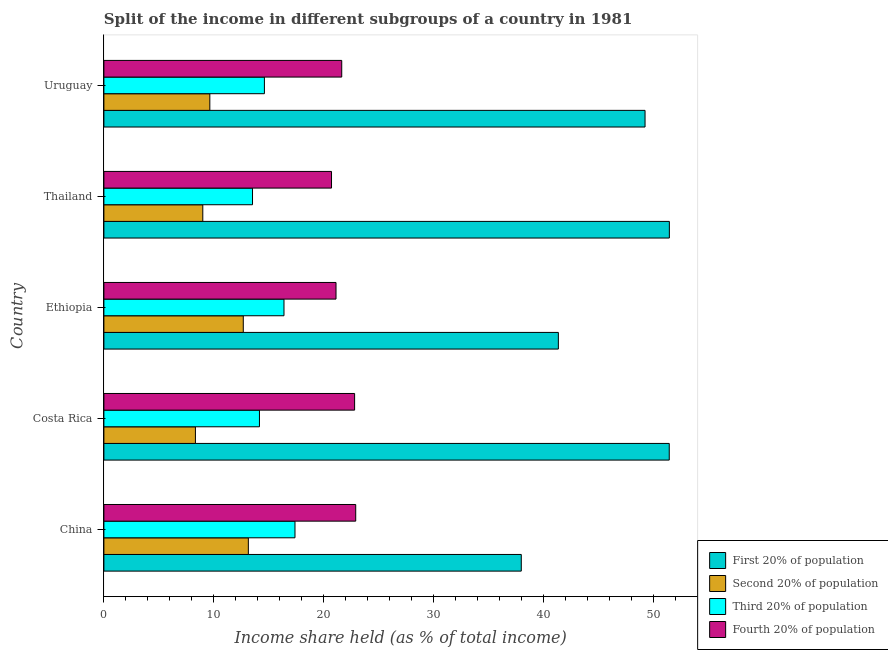How many groups of bars are there?
Offer a very short reply. 5. Are the number of bars per tick equal to the number of legend labels?
Your answer should be very brief. Yes. Are the number of bars on each tick of the Y-axis equal?
Your answer should be compact. Yes. How many bars are there on the 3rd tick from the top?
Provide a succinct answer. 4. How many bars are there on the 1st tick from the bottom?
Ensure brevity in your answer.  4. What is the label of the 1st group of bars from the top?
Keep it short and to the point. Uruguay. What is the share of the income held by second 20% of the population in Uruguay?
Offer a very short reply. 9.63. Across all countries, what is the maximum share of the income held by first 20% of the population?
Your response must be concise. 51.4. Across all countries, what is the minimum share of the income held by third 20% of the population?
Offer a very short reply. 13.51. In which country was the share of the income held by third 20% of the population maximum?
Ensure brevity in your answer.  China. In which country was the share of the income held by third 20% of the population minimum?
Give a very brief answer. Thailand. What is the total share of the income held by first 20% of the population in the graph?
Ensure brevity in your answer.  231.23. What is the difference between the share of the income held by second 20% of the population in China and that in Uruguay?
Ensure brevity in your answer.  3.5. What is the difference between the share of the income held by first 20% of the population in Costa Rica and the share of the income held by third 20% of the population in Uruguay?
Make the answer very short. 36.8. What is the average share of the income held by first 20% of the population per country?
Make the answer very short. 46.25. What is the difference between the share of the income held by fourth 20% of the population and share of the income held by first 20% of the population in Ethiopia?
Your answer should be very brief. -20.21. In how many countries, is the share of the income held by third 20% of the population greater than 8 %?
Provide a succinct answer. 5. What is the ratio of the share of the income held by third 20% of the population in Costa Rica to that in Ethiopia?
Provide a short and direct response. 0.86. Is the share of the income held by first 20% of the population in Thailand less than that in Uruguay?
Provide a short and direct response. No. What is the difference between the highest and the second highest share of the income held by second 20% of the population?
Give a very brief answer. 0.46. What is the difference between the highest and the lowest share of the income held by fourth 20% of the population?
Make the answer very short. 2.2. In how many countries, is the share of the income held by fourth 20% of the population greater than the average share of the income held by fourth 20% of the population taken over all countries?
Your answer should be very brief. 2. Is it the case that in every country, the sum of the share of the income held by second 20% of the population and share of the income held by first 20% of the population is greater than the sum of share of the income held by third 20% of the population and share of the income held by fourth 20% of the population?
Make the answer very short. Yes. What does the 3rd bar from the top in Costa Rica represents?
Offer a very short reply. Second 20% of population. What does the 1st bar from the bottom in Thailand represents?
Make the answer very short. First 20% of population. How many bars are there?
Ensure brevity in your answer.  20. What is the difference between two consecutive major ticks on the X-axis?
Your answer should be very brief. 10. Does the graph contain any zero values?
Your answer should be compact. No. Does the graph contain grids?
Offer a very short reply. No. Where does the legend appear in the graph?
Your answer should be compact. Bottom right. How many legend labels are there?
Your response must be concise. 4. What is the title of the graph?
Ensure brevity in your answer.  Split of the income in different subgroups of a country in 1981. What is the label or title of the X-axis?
Provide a short and direct response. Income share held (as % of total income). What is the Income share held (as % of total income) of First 20% of population in China?
Provide a short and direct response. 37.94. What is the Income share held (as % of total income) in Second 20% of population in China?
Offer a terse response. 13.13. What is the Income share held (as % of total income) in Third 20% of population in China?
Keep it short and to the point. 17.37. What is the Income share held (as % of total income) of Fourth 20% of population in China?
Offer a very short reply. 22.89. What is the Income share held (as % of total income) in First 20% of population in Costa Rica?
Offer a very short reply. 51.39. What is the Income share held (as % of total income) in Second 20% of population in Costa Rica?
Your answer should be compact. 8.32. What is the Income share held (as % of total income) of Third 20% of population in Costa Rica?
Keep it short and to the point. 14.14. What is the Income share held (as % of total income) in Fourth 20% of population in Costa Rica?
Your answer should be very brief. 22.79. What is the Income share held (as % of total income) of First 20% of population in Ethiopia?
Give a very brief answer. 41.31. What is the Income share held (as % of total income) in Second 20% of population in Ethiopia?
Offer a terse response. 12.67. What is the Income share held (as % of total income) in Third 20% of population in Ethiopia?
Provide a succinct answer. 16.37. What is the Income share held (as % of total income) of Fourth 20% of population in Ethiopia?
Provide a succinct answer. 21.1. What is the Income share held (as % of total income) of First 20% of population in Thailand?
Provide a short and direct response. 51.4. What is the Income share held (as % of total income) in Second 20% of population in Thailand?
Give a very brief answer. 8.99. What is the Income share held (as % of total income) of Third 20% of population in Thailand?
Make the answer very short. 13.51. What is the Income share held (as % of total income) in Fourth 20% of population in Thailand?
Offer a terse response. 20.69. What is the Income share held (as % of total income) in First 20% of population in Uruguay?
Provide a succinct answer. 49.19. What is the Income share held (as % of total income) of Second 20% of population in Uruguay?
Keep it short and to the point. 9.63. What is the Income share held (as % of total income) of Third 20% of population in Uruguay?
Provide a succinct answer. 14.59. What is the Income share held (as % of total income) in Fourth 20% of population in Uruguay?
Your answer should be very brief. 21.62. Across all countries, what is the maximum Income share held (as % of total income) in First 20% of population?
Keep it short and to the point. 51.4. Across all countries, what is the maximum Income share held (as % of total income) in Second 20% of population?
Keep it short and to the point. 13.13. Across all countries, what is the maximum Income share held (as % of total income) of Third 20% of population?
Offer a terse response. 17.37. Across all countries, what is the maximum Income share held (as % of total income) in Fourth 20% of population?
Make the answer very short. 22.89. Across all countries, what is the minimum Income share held (as % of total income) in First 20% of population?
Keep it short and to the point. 37.94. Across all countries, what is the minimum Income share held (as % of total income) in Second 20% of population?
Ensure brevity in your answer.  8.32. Across all countries, what is the minimum Income share held (as % of total income) of Third 20% of population?
Offer a terse response. 13.51. Across all countries, what is the minimum Income share held (as % of total income) of Fourth 20% of population?
Your response must be concise. 20.69. What is the total Income share held (as % of total income) in First 20% of population in the graph?
Keep it short and to the point. 231.23. What is the total Income share held (as % of total income) of Second 20% of population in the graph?
Keep it short and to the point. 52.74. What is the total Income share held (as % of total income) of Third 20% of population in the graph?
Keep it short and to the point. 75.98. What is the total Income share held (as % of total income) in Fourth 20% of population in the graph?
Offer a terse response. 109.09. What is the difference between the Income share held (as % of total income) in First 20% of population in China and that in Costa Rica?
Your response must be concise. -13.45. What is the difference between the Income share held (as % of total income) of Second 20% of population in China and that in Costa Rica?
Offer a terse response. 4.81. What is the difference between the Income share held (as % of total income) in Third 20% of population in China and that in Costa Rica?
Provide a succinct answer. 3.23. What is the difference between the Income share held (as % of total income) in First 20% of population in China and that in Ethiopia?
Your answer should be compact. -3.37. What is the difference between the Income share held (as % of total income) of Second 20% of population in China and that in Ethiopia?
Your answer should be very brief. 0.46. What is the difference between the Income share held (as % of total income) of Fourth 20% of population in China and that in Ethiopia?
Offer a very short reply. 1.79. What is the difference between the Income share held (as % of total income) in First 20% of population in China and that in Thailand?
Offer a very short reply. -13.46. What is the difference between the Income share held (as % of total income) of Second 20% of population in China and that in Thailand?
Provide a succinct answer. 4.14. What is the difference between the Income share held (as % of total income) of Third 20% of population in China and that in Thailand?
Make the answer very short. 3.86. What is the difference between the Income share held (as % of total income) of First 20% of population in China and that in Uruguay?
Give a very brief answer. -11.25. What is the difference between the Income share held (as % of total income) of Third 20% of population in China and that in Uruguay?
Give a very brief answer. 2.78. What is the difference between the Income share held (as % of total income) of Fourth 20% of population in China and that in Uruguay?
Provide a short and direct response. 1.27. What is the difference between the Income share held (as % of total income) of First 20% of population in Costa Rica and that in Ethiopia?
Give a very brief answer. 10.08. What is the difference between the Income share held (as % of total income) of Second 20% of population in Costa Rica and that in Ethiopia?
Make the answer very short. -4.35. What is the difference between the Income share held (as % of total income) in Third 20% of population in Costa Rica and that in Ethiopia?
Offer a very short reply. -2.23. What is the difference between the Income share held (as % of total income) in Fourth 20% of population in Costa Rica and that in Ethiopia?
Provide a succinct answer. 1.69. What is the difference between the Income share held (as % of total income) of First 20% of population in Costa Rica and that in Thailand?
Provide a succinct answer. -0.01. What is the difference between the Income share held (as % of total income) of Second 20% of population in Costa Rica and that in Thailand?
Your answer should be very brief. -0.67. What is the difference between the Income share held (as % of total income) of Third 20% of population in Costa Rica and that in Thailand?
Offer a very short reply. 0.63. What is the difference between the Income share held (as % of total income) in Fourth 20% of population in Costa Rica and that in Thailand?
Your response must be concise. 2.1. What is the difference between the Income share held (as % of total income) in First 20% of population in Costa Rica and that in Uruguay?
Give a very brief answer. 2.2. What is the difference between the Income share held (as % of total income) in Second 20% of population in Costa Rica and that in Uruguay?
Your answer should be very brief. -1.31. What is the difference between the Income share held (as % of total income) in Third 20% of population in Costa Rica and that in Uruguay?
Provide a succinct answer. -0.45. What is the difference between the Income share held (as % of total income) in Fourth 20% of population in Costa Rica and that in Uruguay?
Provide a short and direct response. 1.17. What is the difference between the Income share held (as % of total income) of First 20% of population in Ethiopia and that in Thailand?
Your answer should be very brief. -10.09. What is the difference between the Income share held (as % of total income) of Second 20% of population in Ethiopia and that in Thailand?
Offer a terse response. 3.68. What is the difference between the Income share held (as % of total income) of Third 20% of population in Ethiopia and that in Thailand?
Keep it short and to the point. 2.86. What is the difference between the Income share held (as % of total income) of Fourth 20% of population in Ethiopia and that in Thailand?
Make the answer very short. 0.41. What is the difference between the Income share held (as % of total income) in First 20% of population in Ethiopia and that in Uruguay?
Your response must be concise. -7.88. What is the difference between the Income share held (as % of total income) of Second 20% of population in Ethiopia and that in Uruguay?
Your answer should be very brief. 3.04. What is the difference between the Income share held (as % of total income) of Third 20% of population in Ethiopia and that in Uruguay?
Make the answer very short. 1.78. What is the difference between the Income share held (as % of total income) in Fourth 20% of population in Ethiopia and that in Uruguay?
Keep it short and to the point. -0.52. What is the difference between the Income share held (as % of total income) in First 20% of population in Thailand and that in Uruguay?
Ensure brevity in your answer.  2.21. What is the difference between the Income share held (as % of total income) of Second 20% of population in Thailand and that in Uruguay?
Your answer should be compact. -0.64. What is the difference between the Income share held (as % of total income) in Third 20% of population in Thailand and that in Uruguay?
Offer a terse response. -1.08. What is the difference between the Income share held (as % of total income) in Fourth 20% of population in Thailand and that in Uruguay?
Your response must be concise. -0.93. What is the difference between the Income share held (as % of total income) of First 20% of population in China and the Income share held (as % of total income) of Second 20% of population in Costa Rica?
Give a very brief answer. 29.62. What is the difference between the Income share held (as % of total income) of First 20% of population in China and the Income share held (as % of total income) of Third 20% of population in Costa Rica?
Ensure brevity in your answer.  23.8. What is the difference between the Income share held (as % of total income) in First 20% of population in China and the Income share held (as % of total income) in Fourth 20% of population in Costa Rica?
Your response must be concise. 15.15. What is the difference between the Income share held (as % of total income) of Second 20% of population in China and the Income share held (as % of total income) of Third 20% of population in Costa Rica?
Your answer should be compact. -1.01. What is the difference between the Income share held (as % of total income) in Second 20% of population in China and the Income share held (as % of total income) in Fourth 20% of population in Costa Rica?
Your answer should be very brief. -9.66. What is the difference between the Income share held (as % of total income) of Third 20% of population in China and the Income share held (as % of total income) of Fourth 20% of population in Costa Rica?
Give a very brief answer. -5.42. What is the difference between the Income share held (as % of total income) of First 20% of population in China and the Income share held (as % of total income) of Second 20% of population in Ethiopia?
Provide a short and direct response. 25.27. What is the difference between the Income share held (as % of total income) in First 20% of population in China and the Income share held (as % of total income) in Third 20% of population in Ethiopia?
Your answer should be compact. 21.57. What is the difference between the Income share held (as % of total income) of First 20% of population in China and the Income share held (as % of total income) of Fourth 20% of population in Ethiopia?
Provide a short and direct response. 16.84. What is the difference between the Income share held (as % of total income) in Second 20% of population in China and the Income share held (as % of total income) in Third 20% of population in Ethiopia?
Your answer should be compact. -3.24. What is the difference between the Income share held (as % of total income) in Second 20% of population in China and the Income share held (as % of total income) in Fourth 20% of population in Ethiopia?
Offer a very short reply. -7.97. What is the difference between the Income share held (as % of total income) of Third 20% of population in China and the Income share held (as % of total income) of Fourth 20% of population in Ethiopia?
Ensure brevity in your answer.  -3.73. What is the difference between the Income share held (as % of total income) of First 20% of population in China and the Income share held (as % of total income) of Second 20% of population in Thailand?
Keep it short and to the point. 28.95. What is the difference between the Income share held (as % of total income) of First 20% of population in China and the Income share held (as % of total income) of Third 20% of population in Thailand?
Your answer should be very brief. 24.43. What is the difference between the Income share held (as % of total income) of First 20% of population in China and the Income share held (as % of total income) of Fourth 20% of population in Thailand?
Make the answer very short. 17.25. What is the difference between the Income share held (as % of total income) in Second 20% of population in China and the Income share held (as % of total income) in Third 20% of population in Thailand?
Your response must be concise. -0.38. What is the difference between the Income share held (as % of total income) of Second 20% of population in China and the Income share held (as % of total income) of Fourth 20% of population in Thailand?
Keep it short and to the point. -7.56. What is the difference between the Income share held (as % of total income) of Third 20% of population in China and the Income share held (as % of total income) of Fourth 20% of population in Thailand?
Provide a succinct answer. -3.32. What is the difference between the Income share held (as % of total income) of First 20% of population in China and the Income share held (as % of total income) of Second 20% of population in Uruguay?
Offer a terse response. 28.31. What is the difference between the Income share held (as % of total income) of First 20% of population in China and the Income share held (as % of total income) of Third 20% of population in Uruguay?
Offer a terse response. 23.35. What is the difference between the Income share held (as % of total income) in First 20% of population in China and the Income share held (as % of total income) in Fourth 20% of population in Uruguay?
Provide a succinct answer. 16.32. What is the difference between the Income share held (as % of total income) of Second 20% of population in China and the Income share held (as % of total income) of Third 20% of population in Uruguay?
Give a very brief answer. -1.46. What is the difference between the Income share held (as % of total income) in Second 20% of population in China and the Income share held (as % of total income) in Fourth 20% of population in Uruguay?
Offer a very short reply. -8.49. What is the difference between the Income share held (as % of total income) in Third 20% of population in China and the Income share held (as % of total income) in Fourth 20% of population in Uruguay?
Provide a succinct answer. -4.25. What is the difference between the Income share held (as % of total income) of First 20% of population in Costa Rica and the Income share held (as % of total income) of Second 20% of population in Ethiopia?
Your answer should be very brief. 38.72. What is the difference between the Income share held (as % of total income) of First 20% of population in Costa Rica and the Income share held (as % of total income) of Third 20% of population in Ethiopia?
Provide a short and direct response. 35.02. What is the difference between the Income share held (as % of total income) of First 20% of population in Costa Rica and the Income share held (as % of total income) of Fourth 20% of population in Ethiopia?
Your answer should be compact. 30.29. What is the difference between the Income share held (as % of total income) of Second 20% of population in Costa Rica and the Income share held (as % of total income) of Third 20% of population in Ethiopia?
Provide a short and direct response. -8.05. What is the difference between the Income share held (as % of total income) of Second 20% of population in Costa Rica and the Income share held (as % of total income) of Fourth 20% of population in Ethiopia?
Provide a short and direct response. -12.78. What is the difference between the Income share held (as % of total income) in Third 20% of population in Costa Rica and the Income share held (as % of total income) in Fourth 20% of population in Ethiopia?
Provide a succinct answer. -6.96. What is the difference between the Income share held (as % of total income) in First 20% of population in Costa Rica and the Income share held (as % of total income) in Second 20% of population in Thailand?
Provide a succinct answer. 42.4. What is the difference between the Income share held (as % of total income) of First 20% of population in Costa Rica and the Income share held (as % of total income) of Third 20% of population in Thailand?
Provide a succinct answer. 37.88. What is the difference between the Income share held (as % of total income) in First 20% of population in Costa Rica and the Income share held (as % of total income) in Fourth 20% of population in Thailand?
Your answer should be compact. 30.7. What is the difference between the Income share held (as % of total income) in Second 20% of population in Costa Rica and the Income share held (as % of total income) in Third 20% of population in Thailand?
Your answer should be very brief. -5.19. What is the difference between the Income share held (as % of total income) in Second 20% of population in Costa Rica and the Income share held (as % of total income) in Fourth 20% of population in Thailand?
Give a very brief answer. -12.37. What is the difference between the Income share held (as % of total income) of Third 20% of population in Costa Rica and the Income share held (as % of total income) of Fourth 20% of population in Thailand?
Offer a terse response. -6.55. What is the difference between the Income share held (as % of total income) in First 20% of population in Costa Rica and the Income share held (as % of total income) in Second 20% of population in Uruguay?
Make the answer very short. 41.76. What is the difference between the Income share held (as % of total income) in First 20% of population in Costa Rica and the Income share held (as % of total income) in Third 20% of population in Uruguay?
Provide a short and direct response. 36.8. What is the difference between the Income share held (as % of total income) in First 20% of population in Costa Rica and the Income share held (as % of total income) in Fourth 20% of population in Uruguay?
Make the answer very short. 29.77. What is the difference between the Income share held (as % of total income) of Second 20% of population in Costa Rica and the Income share held (as % of total income) of Third 20% of population in Uruguay?
Offer a very short reply. -6.27. What is the difference between the Income share held (as % of total income) of Second 20% of population in Costa Rica and the Income share held (as % of total income) of Fourth 20% of population in Uruguay?
Keep it short and to the point. -13.3. What is the difference between the Income share held (as % of total income) in Third 20% of population in Costa Rica and the Income share held (as % of total income) in Fourth 20% of population in Uruguay?
Provide a succinct answer. -7.48. What is the difference between the Income share held (as % of total income) of First 20% of population in Ethiopia and the Income share held (as % of total income) of Second 20% of population in Thailand?
Provide a succinct answer. 32.32. What is the difference between the Income share held (as % of total income) in First 20% of population in Ethiopia and the Income share held (as % of total income) in Third 20% of population in Thailand?
Offer a very short reply. 27.8. What is the difference between the Income share held (as % of total income) in First 20% of population in Ethiopia and the Income share held (as % of total income) in Fourth 20% of population in Thailand?
Keep it short and to the point. 20.62. What is the difference between the Income share held (as % of total income) of Second 20% of population in Ethiopia and the Income share held (as % of total income) of Third 20% of population in Thailand?
Your answer should be compact. -0.84. What is the difference between the Income share held (as % of total income) in Second 20% of population in Ethiopia and the Income share held (as % of total income) in Fourth 20% of population in Thailand?
Offer a terse response. -8.02. What is the difference between the Income share held (as % of total income) in Third 20% of population in Ethiopia and the Income share held (as % of total income) in Fourth 20% of population in Thailand?
Your response must be concise. -4.32. What is the difference between the Income share held (as % of total income) in First 20% of population in Ethiopia and the Income share held (as % of total income) in Second 20% of population in Uruguay?
Give a very brief answer. 31.68. What is the difference between the Income share held (as % of total income) of First 20% of population in Ethiopia and the Income share held (as % of total income) of Third 20% of population in Uruguay?
Ensure brevity in your answer.  26.72. What is the difference between the Income share held (as % of total income) in First 20% of population in Ethiopia and the Income share held (as % of total income) in Fourth 20% of population in Uruguay?
Make the answer very short. 19.69. What is the difference between the Income share held (as % of total income) in Second 20% of population in Ethiopia and the Income share held (as % of total income) in Third 20% of population in Uruguay?
Offer a very short reply. -1.92. What is the difference between the Income share held (as % of total income) in Second 20% of population in Ethiopia and the Income share held (as % of total income) in Fourth 20% of population in Uruguay?
Keep it short and to the point. -8.95. What is the difference between the Income share held (as % of total income) of Third 20% of population in Ethiopia and the Income share held (as % of total income) of Fourth 20% of population in Uruguay?
Offer a very short reply. -5.25. What is the difference between the Income share held (as % of total income) of First 20% of population in Thailand and the Income share held (as % of total income) of Second 20% of population in Uruguay?
Offer a terse response. 41.77. What is the difference between the Income share held (as % of total income) of First 20% of population in Thailand and the Income share held (as % of total income) of Third 20% of population in Uruguay?
Provide a succinct answer. 36.81. What is the difference between the Income share held (as % of total income) of First 20% of population in Thailand and the Income share held (as % of total income) of Fourth 20% of population in Uruguay?
Ensure brevity in your answer.  29.78. What is the difference between the Income share held (as % of total income) of Second 20% of population in Thailand and the Income share held (as % of total income) of Third 20% of population in Uruguay?
Keep it short and to the point. -5.6. What is the difference between the Income share held (as % of total income) in Second 20% of population in Thailand and the Income share held (as % of total income) in Fourth 20% of population in Uruguay?
Give a very brief answer. -12.63. What is the difference between the Income share held (as % of total income) in Third 20% of population in Thailand and the Income share held (as % of total income) in Fourth 20% of population in Uruguay?
Your response must be concise. -8.11. What is the average Income share held (as % of total income) in First 20% of population per country?
Offer a terse response. 46.25. What is the average Income share held (as % of total income) of Second 20% of population per country?
Offer a terse response. 10.55. What is the average Income share held (as % of total income) of Third 20% of population per country?
Your response must be concise. 15.2. What is the average Income share held (as % of total income) of Fourth 20% of population per country?
Your response must be concise. 21.82. What is the difference between the Income share held (as % of total income) of First 20% of population and Income share held (as % of total income) of Second 20% of population in China?
Give a very brief answer. 24.81. What is the difference between the Income share held (as % of total income) in First 20% of population and Income share held (as % of total income) in Third 20% of population in China?
Ensure brevity in your answer.  20.57. What is the difference between the Income share held (as % of total income) in First 20% of population and Income share held (as % of total income) in Fourth 20% of population in China?
Provide a succinct answer. 15.05. What is the difference between the Income share held (as % of total income) of Second 20% of population and Income share held (as % of total income) of Third 20% of population in China?
Your answer should be very brief. -4.24. What is the difference between the Income share held (as % of total income) in Second 20% of population and Income share held (as % of total income) in Fourth 20% of population in China?
Give a very brief answer. -9.76. What is the difference between the Income share held (as % of total income) of Third 20% of population and Income share held (as % of total income) of Fourth 20% of population in China?
Provide a short and direct response. -5.52. What is the difference between the Income share held (as % of total income) of First 20% of population and Income share held (as % of total income) of Second 20% of population in Costa Rica?
Make the answer very short. 43.07. What is the difference between the Income share held (as % of total income) of First 20% of population and Income share held (as % of total income) of Third 20% of population in Costa Rica?
Your answer should be very brief. 37.25. What is the difference between the Income share held (as % of total income) in First 20% of population and Income share held (as % of total income) in Fourth 20% of population in Costa Rica?
Provide a short and direct response. 28.6. What is the difference between the Income share held (as % of total income) of Second 20% of population and Income share held (as % of total income) of Third 20% of population in Costa Rica?
Make the answer very short. -5.82. What is the difference between the Income share held (as % of total income) in Second 20% of population and Income share held (as % of total income) in Fourth 20% of population in Costa Rica?
Your response must be concise. -14.47. What is the difference between the Income share held (as % of total income) in Third 20% of population and Income share held (as % of total income) in Fourth 20% of population in Costa Rica?
Offer a terse response. -8.65. What is the difference between the Income share held (as % of total income) of First 20% of population and Income share held (as % of total income) of Second 20% of population in Ethiopia?
Offer a very short reply. 28.64. What is the difference between the Income share held (as % of total income) of First 20% of population and Income share held (as % of total income) of Third 20% of population in Ethiopia?
Keep it short and to the point. 24.94. What is the difference between the Income share held (as % of total income) in First 20% of population and Income share held (as % of total income) in Fourth 20% of population in Ethiopia?
Give a very brief answer. 20.21. What is the difference between the Income share held (as % of total income) of Second 20% of population and Income share held (as % of total income) of Third 20% of population in Ethiopia?
Give a very brief answer. -3.7. What is the difference between the Income share held (as % of total income) of Second 20% of population and Income share held (as % of total income) of Fourth 20% of population in Ethiopia?
Provide a succinct answer. -8.43. What is the difference between the Income share held (as % of total income) in Third 20% of population and Income share held (as % of total income) in Fourth 20% of population in Ethiopia?
Your answer should be compact. -4.73. What is the difference between the Income share held (as % of total income) of First 20% of population and Income share held (as % of total income) of Second 20% of population in Thailand?
Your answer should be very brief. 42.41. What is the difference between the Income share held (as % of total income) in First 20% of population and Income share held (as % of total income) in Third 20% of population in Thailand?
Give a very brief answer. 37.89. What is the difference between the Income share held (as % of total income) of First 20% of population and Income share held (as % of total income) of Fourth 20% of population in Thailand?
Ensure brevity in your answer.  30.71. What is the difference between the Income share held (as % of total income) of Second 20% of population and Income share held (as % of total income) of Third 20% of population in Thailand?
Offer a very short reply. -4.52. What is the difference between the Income share held (as % of total income) in Second 20% of population and Income share held (as % of total income) in Fourth 20% of population in Thailand?
Offer a terse response. -11.7. What is the difference between the Income share held (as % of total income) of Third 20% of population and Income share held (as % of total income) of Fourth 20% of population in Thailand?
Your response must be concise. -7.18. What is the difference between the Income share held (as % of total income) in First 20% of population and Income share held (as % of total income) in Second 20% of population in Uruguay?
Your answer should be compact. 39.56. What is the difference between the Income share held (as % of total income) in First 20% of population and Income share held (as % of total income) in Third 20% of population in Uruguay?
Make the answer very short. 34.6. What is the difference between the Income share held (as % of total income) of First 20% of population and Income share held (as % of total income) of Fourth 20% of population in Uruguay?
Keep it short and to the point. 27.57. What is the difference between the Income share held (as % of total income) of Second 20% of population and Income share held (as % of total income) of Third 20% of population in Uruguay?
Ensure brevity in your answer.  -4.96. What is the difference between the Income share held (as % of total income) in Second 20% of population and Income share held (as % of total income) in Fourth 20% of population in Uruguay?
Your response must be concise. -11.99. What is the difference between the Income share held (as % of total income) of Third 20% of population and Income share held (as % of total income) of Fourth 20% of population in Uruguay?
Your response must be concise. -7.03. What is the ratio of the Income share held (as % of total income) of First 20% of population in China to that in Costa Rica?
Your answer should be very brief. 0.74. What is the ratio of the Income share held (as % of total income) in Second 20% of population in China to that in Costa Rica?
Give a very brief answer. 1.58. What is the ratio of the Income share held (as % of total income) of Third 20% of population in China to that in Costa Rica?
Give a very brief answer. 1.23. What is the ratio of the Income share held (as % of total income) of First 20% of population in China to that in Ethiopia?
Provide a succinct answer. 0.92. What is the ratio of the Income share held (as % of total income) in Second 20% of population in China to that in Ethiopia?
Your response must be concise. 1.04. What is the ratio of the Income share held (as % of total income) of Third 20% of population in China to that in Ethiopia?
Provide a short and direct response. 1.06. What is the ratio of the Income share held (as % of total income) in Fourth 20% of population in China to that in Ethiopia?
Provide a succinct answer. 1.08. What is the ratio of the Income share held (as % of total income) in First 20% of population in China to that in Thailand?
Keep it short and to the point. 0.74. What is the ratio of the Income share held (as % of total income) in Second 20% of population in China to that in Thailand?
Provide a short and direct response. 1.46. What is the ratio of the Income share held (as % of total income) of Third 20% of population in China to that in Thailand?
Give a very brief answer. 1.29. What is the ratio of the Income share held (as % of total income) of Fourth 20% of population in China to that in Thailand?
Keep it short and to the point. 1.11. What is the ratio of the Income share held (as % of total income) in First 20% of population in China to that in Uruguay?
Provide a short and direct response. 0.77. What is the ratio of the Income share held (as % of total income) of Second 20% of population in China to that in Uruguay?
Give a very brief answer. 1.36. What is the ratio of the Income share held (as % of total income) in Third 20% of population in China to that in Uruguay?
Keep it short and to the point. 1.19. What is the ratio of the Income share held (as % of total income) in Fourth 20% of population in China to that in Uruguay?
Your answer should be very brief. 1.06. What is the ratio of the Income share held (as % of total income) of First 20% of population in Costa Rica to that in Ethiopia?
Keep it short and to the point. 1.24. What is the ratio of the Income share held (as % of total income) of Second 20% of population in Costa Rica to that in Ethiopia?
Make the answer very short. 0.66. What is the ratio of the Income share held (as % of total income) of Third 20% of population in Costa Rica to that in Ethiopia?
Offer a terse response. 0.86. What is the ratio of the Income share held (as % of total income) of Fourth 20% of population in Costa Rica to that in Ethiopia?
Provide a short and direct response. 1.08. What is the ratio of the Income share held (as % of total income) of First 20% of population in Costa Rica to that in Thailand?
Offer a very short reply. 1. What is the ratio of the Income share held (as % of total income) in Second 20% of population in Costa Rica to that in Thailand?
Provide a short and direct response. 0.93. What is the ratio of the Income share held (as % of total income) of Third 20% of population in Costa Rica to that in Thailand?
Your answer should be very brief. 1.05. What is the ratio of the Income share held (as % of total income) of Fourth 20% of population in Costa Rica to that in Thailand?
Provide a short and direct response. 1.1. What is the ratio of the Income share held (as % of total income) of First 20% of population in Costa Rica to that in Uruguay?
Your answer should be very brief. 1.04. What is the ratio of the Income share held (as % of total income) of Second 20% of population in Costa Rica to that in Uruguay?
Your answer should be compact. 0.86. What is the ratio of the Income share held (as % of total income) of Third 20% of population in Costa Rica to that in Uruguay?
Your answer should be compact. 0.97. What is the ratio of the Income share held (as % of total income) in Fourth 20% of population in Costa Rica to that in Uruguay?
Your answer should be compact. 1.05. What is the ratio of the Income share held (as % of total income) in First 20% of population in Ethiopia to that in Thailand?
Ensure brevity in your answer.  0.8. What is the ratio of the Income share held (as % of total income) of Second 20% of population in Ethiopia to that in Thailand?
Your answer should be compact. 1.41. What is the ratio of the Income share held (as % of total income) of Third 20% of population in Ethiopia to that in Thailand?
Provide a succinct answer. 1.21. What is the ratio of the Income share held (as % of total income) in Fourth 20% of population in Ethiopia to that in Thailand?
Ensure brevity in your answer.  1.02. What is the ratio of the Income share held (as % of total income) in First 20% of population in Ethiopia to that in Uruguay?
Offer a very short reply. 0.84. What is the ratio of the Income share held (as % of total income) in Second 20% of population in Ethiopia to that in Uruguay?
Offer a very short reply. 1.32. What is the ratio of the Income share held (as % of total income) in Third 20% of population in Ethiopia to that in Uruguay?
Ensure brevity in your answer.  1.12. What is the ratio of the Income share held (as % of total income) of Fourth 20% of population in Ethiopia to that in Uruguay?
Make the answer very short. 0.98. What is the ratio of the Income share held (as % of total income) in First 20% of population in Thailand to that in Uruguay?
Your answer should be compact. 1.04. What is the ratio of the Income share held (as % of total income) in Second 20% of population in Thailand to that in Uruguay?
Provide a succinct answer. 0.93. What is the ratio of the Income share held (as % of total income) of Third 20% of population in Thailand to that in Uruguay?
Give a very brief answer. 0.93. What is the ratio of the Income share held (as % of total income) of Fourth 20% of population in Thailand to that in Uruguay?
Provide a succinct answer. 0.96. What is the difference between the highest and the second highest Income share held (as % of total income) of First 20% of population?
Your answer should be very brief. 0.01. What is the difference between the highest and the second highest Income share held (as % of total income) in Second 20% of population?
Offer a terse response. 0.46. What is the difference between the highest and the second highest Income share held (as % of total income) of Fourth 20% of population?
Ensure brevity in your answer.  0.1. What is the difference between the highest and the lowest Income share held (as % of total income) of First 20% of population?
Provide a succinct answer. 13.46. What is the difference between the highest and the lowest Income share held (as % of total income) in Second 20% of population?
Offer a very short reply. 4.81. What is the difference between the highest and the lowest Income share held (as % of total income) of Third 20% of population?
Offer a terse response. 3.86. What is the difference between the highest and the lowest Income share held (as % of total income) of Fourth 20% of population?
Make the answer very short. 2.2. 